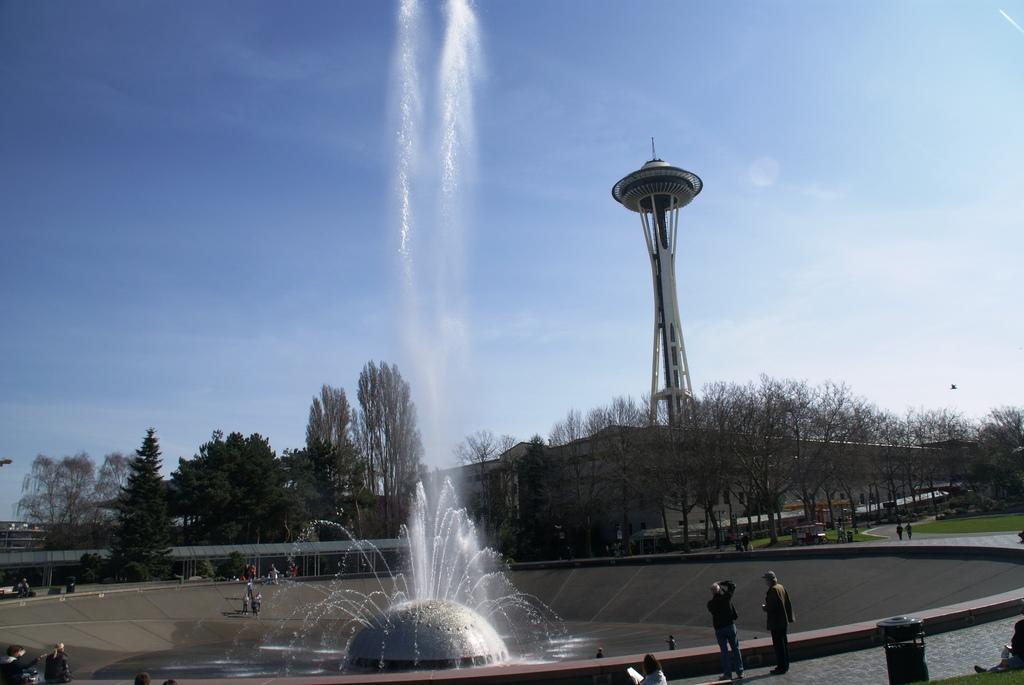What can be seen in the foreground of the image? In the foreground of the image, there are people and fountains. Can you describe the background of the image? In the background of the image, there are people, a shed, house structures, trees, a tower, and the sky. How many elements can be identified in the background of the image? There are seven elements in the background of the image: people, a shed, house structures, trees, a tower, and the sky. What type of bell can be heard ringing in the image? There is no bell present in the image, and therefore no sound can be heard. Can you describe the fog in the image? There is no fog present in the image; the sky is visible in the background. 